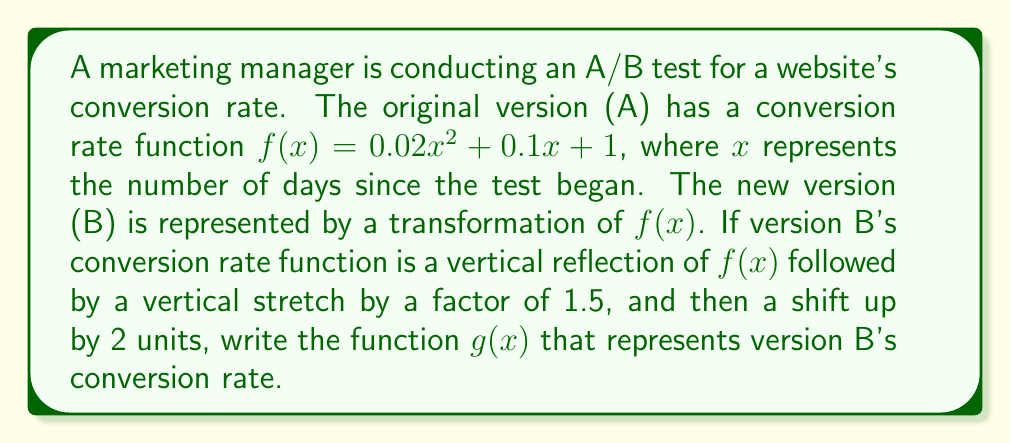Show me your answer to this math problem. Let's approach this step-by-step:

1) Start with the original function: $f(x) = 0.02x^2 + 0.1x + 1$

2) Apply a vertical reflection:
   This means we multiply the function by -1
   $-f(x) = -(0.02x^2 + 0.1x + 1) = -0.02x^2 - 0.1x - 1$

3) Apply a vertical stretch by a factor of 1.5:
   Multiply the function by 1.5
   $1.5(-f(x)) = 1.5(-0.02x^2 - 0.1x - 1) = -0.03x^2 - 0.15x - 1.5$

4) Shift up by 2 units:
   Add 2 to the function
   $g(x) = (-0.03x^2 - 0.15x - 1.5) + 2 = -0.03x^2 - 0.15x + 0.5$

Therefore, the function $g(x)$ representing version B's conversion rate is:
$g(x) = -0.03x^2 - 0.15x + 0.5$
Answer: $g(x) = -0.03x^2 - 0.15x + 0.5$ 